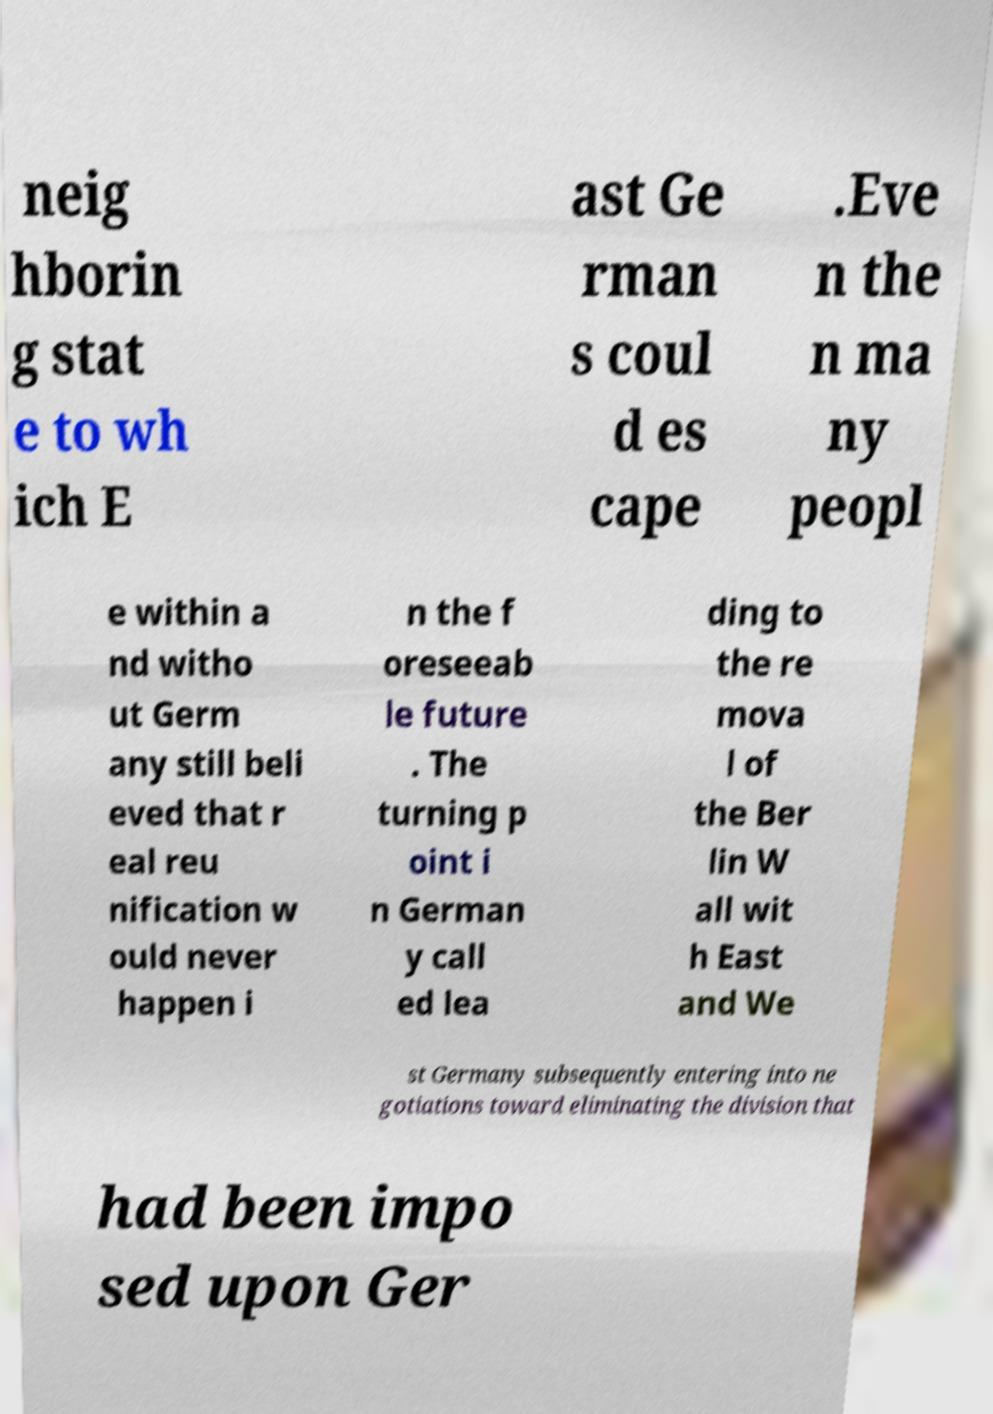I need the written content from this picture converted into text. Can you do that? neig hborin g stat e to wh ich E ast Ge rman s coul d es cape .Eve n the n ma ny peopl e within a nd witho ut Germ any still beli eved that r eal reu nification w ould never happen i n the f oreseeab le future . The turning p oint i n German y call ed lea ding to the re mova l of the Ber lin W all wit h East and We st Germany subsequently entering into ne gotiations toward eliminating the division that had been impo sed upon Ger 